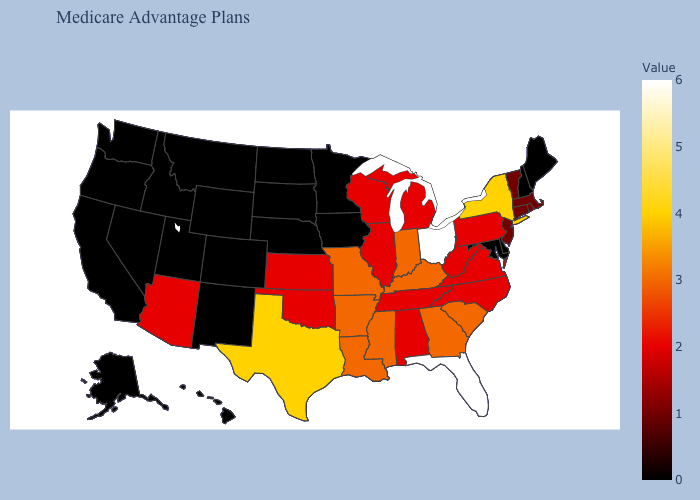Among the states that border California , does Nevada have the lowest value?
Quick response, please. Yes. Does Oregon have the lowest value in the West?
Concise answer only. Yes. Among the states that border Oklahoma , does Arkansas have the highest value?
Keep it brief. No. Which states hav the highest value in the West?
Be succinct. Arizona. Which states have the lowest value in the South?
Answer briefly. Delaware, Maryland. Which states have the highest value in the USA?
Quick response, please. Florida, Ohio. 